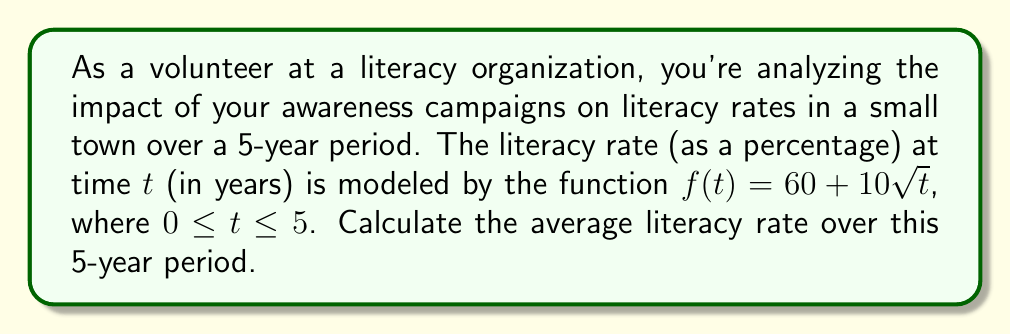Help me with this question. To find the average literacy rate over the 5-year period, we need to calculate the area under the curve of $f(t)$ from $t=0$ to $t=5$, and then divide by the total time period.

1) The area under the curve is given by the definite integral:

   $$\int_0^5 f(t) dt = \int_0^5 (60 + 10\sqrt{t}) dt$$

2) Let's solve this integral:
   $$\int_0^5 (60 + 10\sqrt{t}) dt = \int_0^5 60 dt + \int_0^5 10\sqrt{t} dt$$

3) For the first part:
   $$\int_0^5 60 dt = 60t \bigg|_0^5 = 60(5) - 60(0) = 300$$

4) For the second part:
   $$\int_0^5 10\sqrt{t} dt = 10 \int_0^5 t^{1/2} dt = 10 \cdot \frac{2}{3}t^{3/2} \bigg|_0^5$$
   $$= \frac{20}{3}(5^{3/2} - 0^{3/2}) = \frac{20}{3}(\sqrt{125} - 0) = \frac{20\sqrt{125}}{3}$$

5) The total area is:
   $$300 + \frac{20\sqrt{125}}{3} = 300 + \frac{20 \cdot 5\sqrt{5}}{3} = 300 + \frac{100\sqrt{5}}{3}$$

6) To find the average, we divide this by the time period (5 years):
   $$\frac{300 + \frac{100\sqrt{5}}{3}}{5} = 60 + \frac{20\sqrt{5}}{3}$$

Therefore, the average literacy rate over the 5-year period is $60 + \frac{20\sqrt{5}}{3}$ percent.
Answer: $60 + \frac{20\sqrt{5}}{3}$ percent 